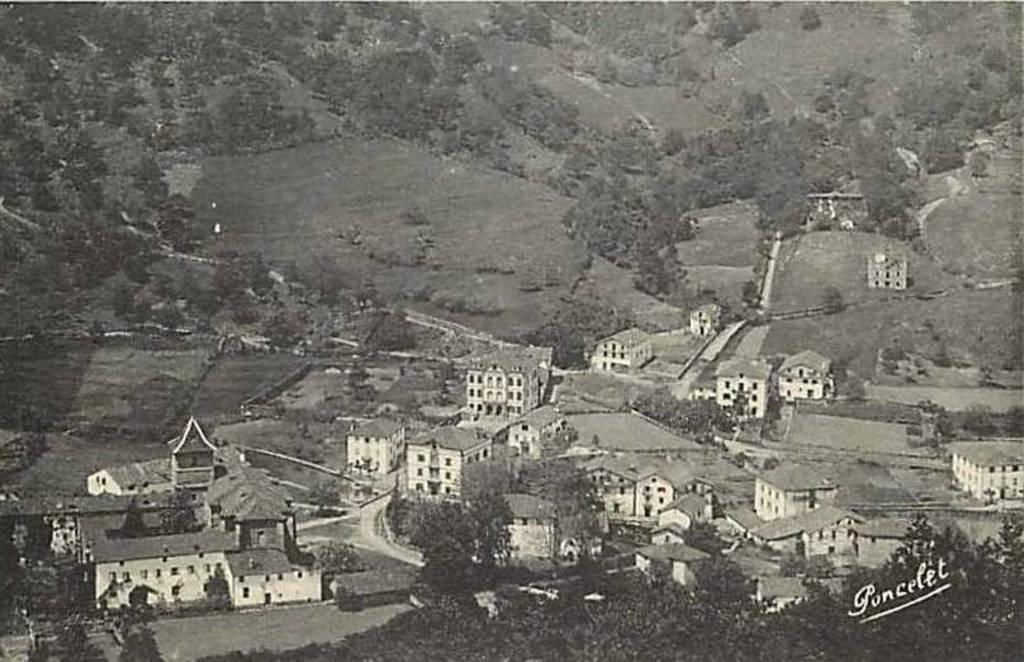What is the color scheme of the image? The image is black and white. What type of structures can be seen in the image? There are buildings in the image. What natural elements are present in the image? There are trees in the image. What man-made elements are present in the image? There are roads in the image. Are there any words or letters visible in the image? Yes, there is text visible in the image. What type of mine can be seen in the image? There is no mine present in the image. How much income is generated by the bean in the image? There is no bean present in the image, and therefore no income can be generated from it. 